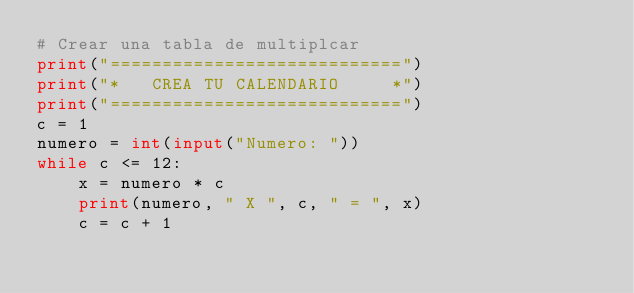<code> <loc_0><loc_0><loc_500><loc_500><_Python_># Crear una tabla de multiplcar
print("============================")
print("*   CREA TU CALENDARIO     *")
print("============================")
c = 1
numero = int(input("Numero: "))
while c <= 12:
    x = numero * c
    print(numero, " X ", c, " = ", x)
    c = c + 1
</code> 